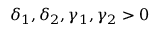<formula> <loc_0><loc_0><loc_500><loc_500>\delta _ { 1 } , \delta _ { 2 } , \gamma _ { 1 } , \gamma _ { 2 } > 0</formula> 